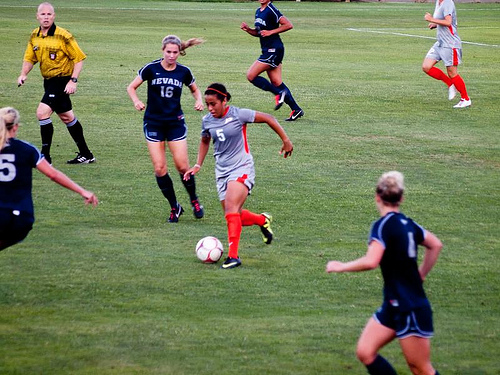<image>
Is there a women on the foot ball? No. The women is not positioned on the foot ball. They may be near each other, but the women is not supported by or resting on top of the foot ball. Where is the female in relation to the round object? Is it to the left of the round object? Yes. From this viewpoint, the female is positioned to the left side relative to the round object. Where is the ball in relation to the girl? Is it under the girl? Yes. The ball is positioned underneath the girl, with the girl above it in the vertical space. Is the man behind the soccer ball? Yes. From this viewpoint, the man is positioned behind the soccer ball, with the soccer ball partially or fully occluding the man. Where is the girl in relation to the girl? Is it behind the girl? No. The girl is not behind the girl. From this viewpoint, the girl appears to be positioned elsewhere in the scene. 